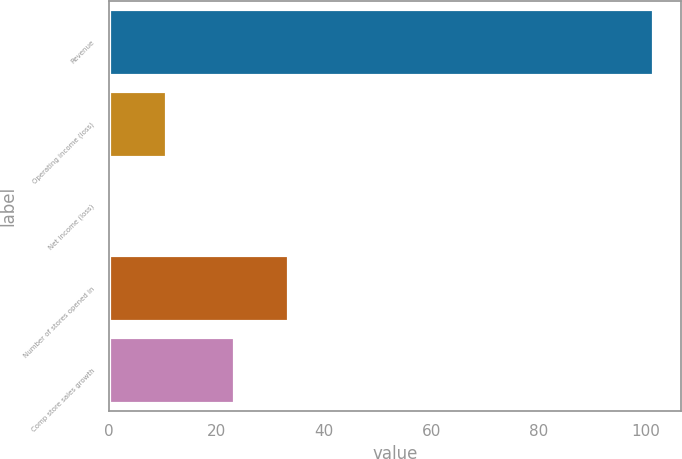Convert chart. <chart><loc_0><loc_0><loc_500><loc_500><bar_chart><fcel>Revenue<fcel>Operating income (loss)<fcel>Net income (loss)<fcel>Number of stores opened in<fcel>Comp store sales growth<nl><fcel>101.4<fcel>10.59<fcel>0.5<fcel>33.29<fcel>23.2<nl></chart> 